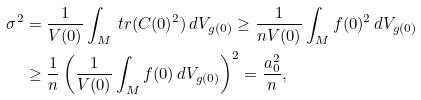<formula> <loc_0><loc_0><loc_500><loc_500>\sigma ^ { 2 } & = \frac { 1 } { V ( 0 ) } \int _ { M } \ t r ( C ( 0 ) ^ { 2 } ) \, d V _ { g ( 0 ) } \geq \frac { 1 } { n V ( 0 ) } \int _ { M } f ( 0 ) ^ { 2 } \, d V _ { g ( 0 ) } \\ & \geq \frac { 1 } { n } \left ( \frac { 1 } { V ( 0 ) } \int _ { M } f ( 0 ) \, d V _ { g ( 0 ) } \right ) ^ { 2 } = \frac { a _ { 0 } ^ { 2 } } { n } ,</formula> 